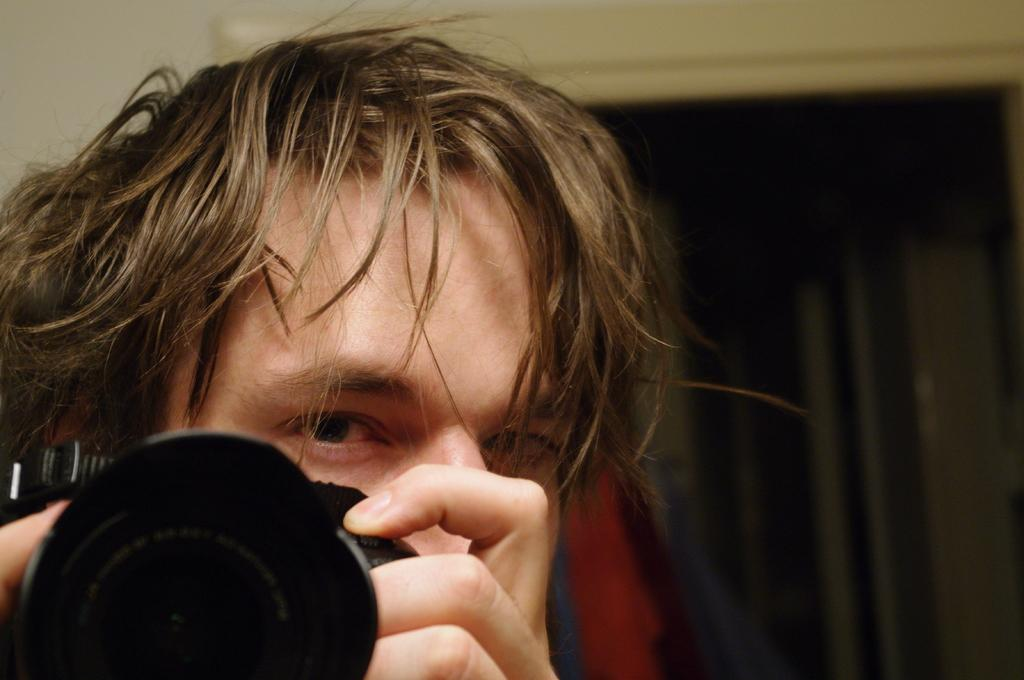What is present in the image? There is a man in the image. What is the man holding in his hand? The man is holding a camera in his hand. Which direction is the man facing? The man is facing the front side. Are the man's friends combing their hair in the winter season in the image? There is no reference to friends, combing hair, or winter season in the image; it only features a man holding a camera and facing the front side. 